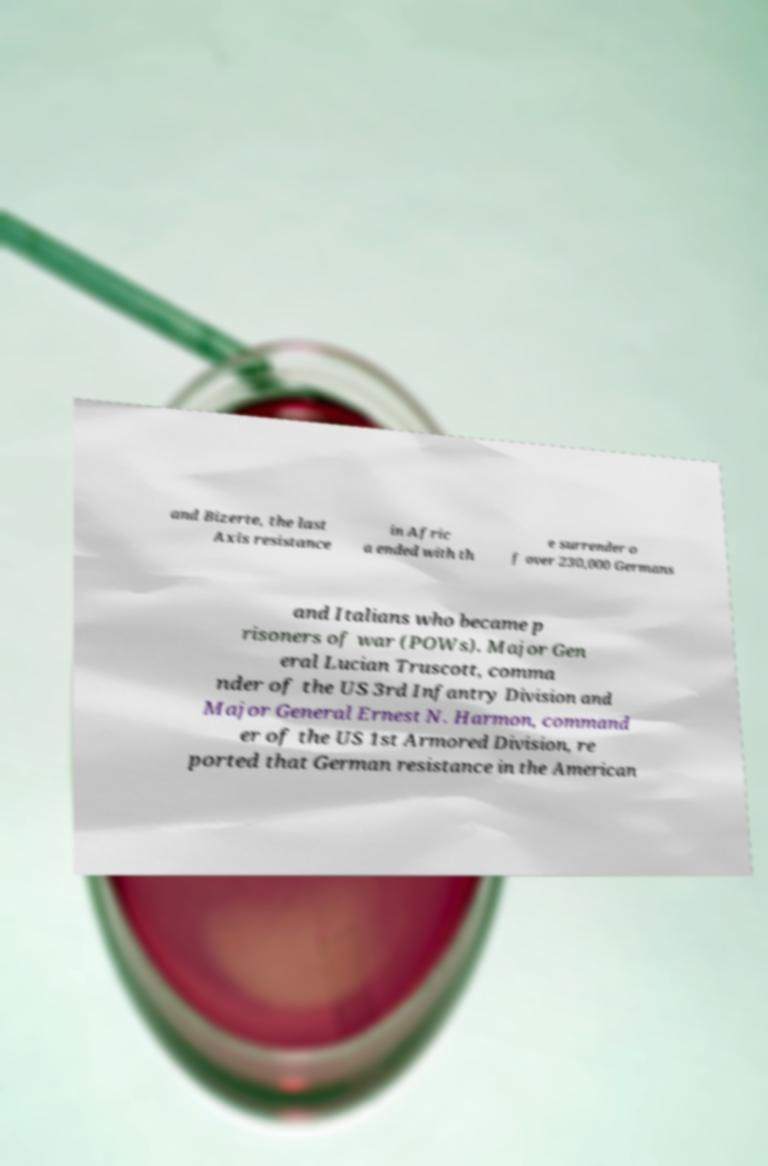Could you extract and type out the text from this image? and Bizerte, the last Axis resistance in Afric a ended with th e surrender o f over 230,000 Germans and Italians who became p risoners of war (POWs). Major Gen eral Lucian Truscott, comma nder of the US 3rd Infantry Division and Major General Ernest N. Harmon, command er of the US 1st Armored Division, re ported that German resistance in the American 